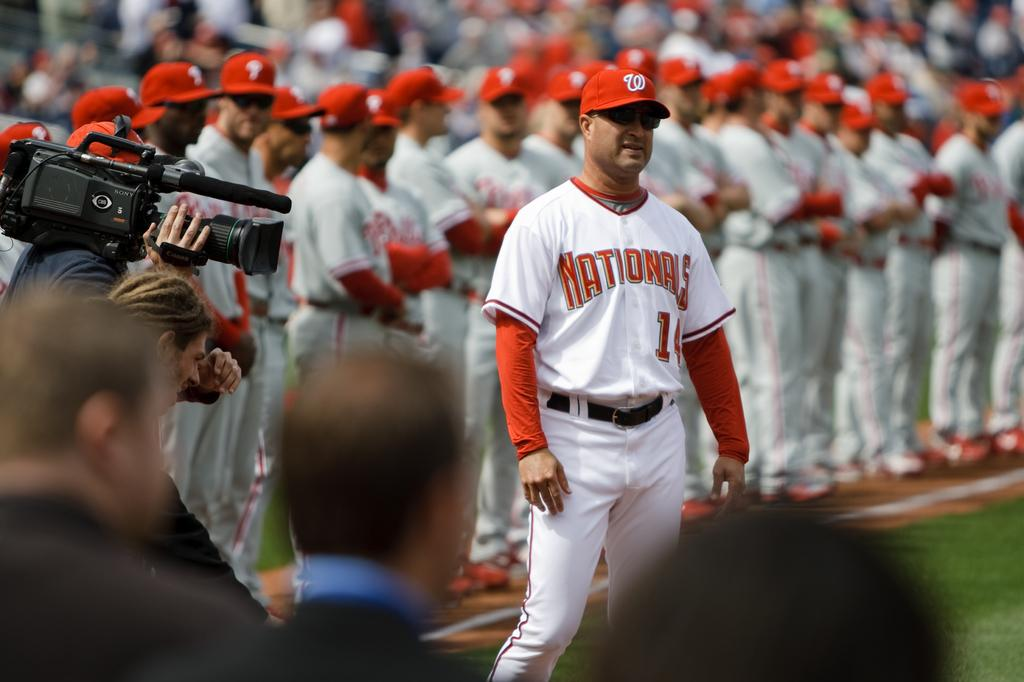<image>
Write a terse but informative summary of the picture. The team shown lined up here is the Nationals 